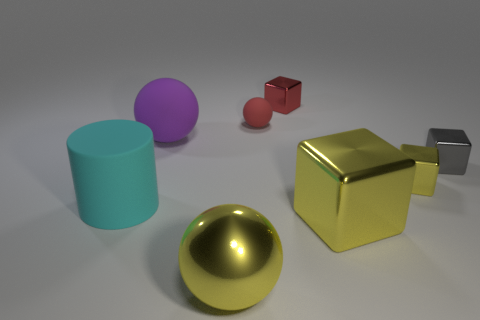What size is the object that is the same color as the tiny ball?
Provide a short and direct response. Small. There is a large rubber object behind the cyan rubber cylinder; what is its color?
Provide a short and direct response. Purple. What number of shiny objects are big purple spheres or large green objects?
Ensure brevity in your answer.  0. There is a large thing that is the same color as the big metal block; what is its shape?
Provide a short and direct response. Sphere. How many red cubes are the same size as the red sphere?
Ensure brevity in your answer.  1. The thing that is in front of the cyan matte cylinder and left of the tiny ball is what color?
Keep it short and to the point. Yellow. What number of objects are either large green balls or balls?
Keep it short and to the point. 3. How many large objects are either cylinders or red things?
Make the answer very short. 1. Is there any other thing that has the same color as the cylinder?
Offer a terse response. No. There is a metallic object that is to the left of the small yellow block and behind the large cyan cylinder; how big is it?
Make the answer very short. Small. 